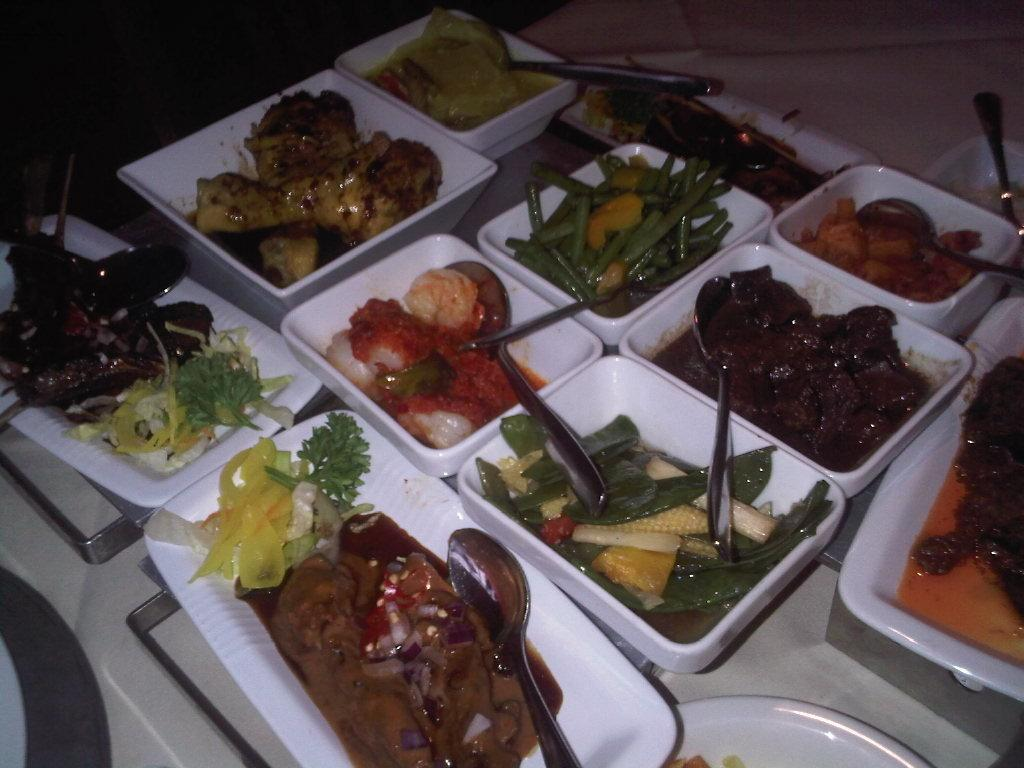What color are the bowls in the image? The bowls in the image are white colored. What is inside the bowls? There are food items in the bowls. What utensils are visible in the image? Spoons are visible in the image. What color is the background of the image? The background of the image is black. Are there any caps visible on the food items in the image? There are no caps visible on the food items in the image. Whose hands can be seen holding the spoons in the image? There are no hands visible in the image; only the bowls, food items, and spoons can be seen. 